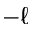Convert formula to latex. <formula><loc_0><loc_0><loc_500><loc_500>- \ell</formula> 